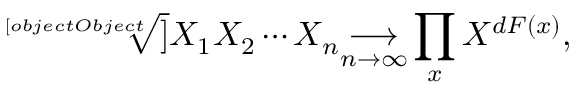<formula> <loc_0><loc_0><loc_500><loc_500>{ \sqrt { [ } [ o b j e c t O b j e c t ] ] { X _ { 1 } X _ { 2 } \cdots X _ { n } } } { \underset { n \to \infty } { \longrightarrow } } \prod _ { x } X ^ { d F ( x ) } ,</formula> 